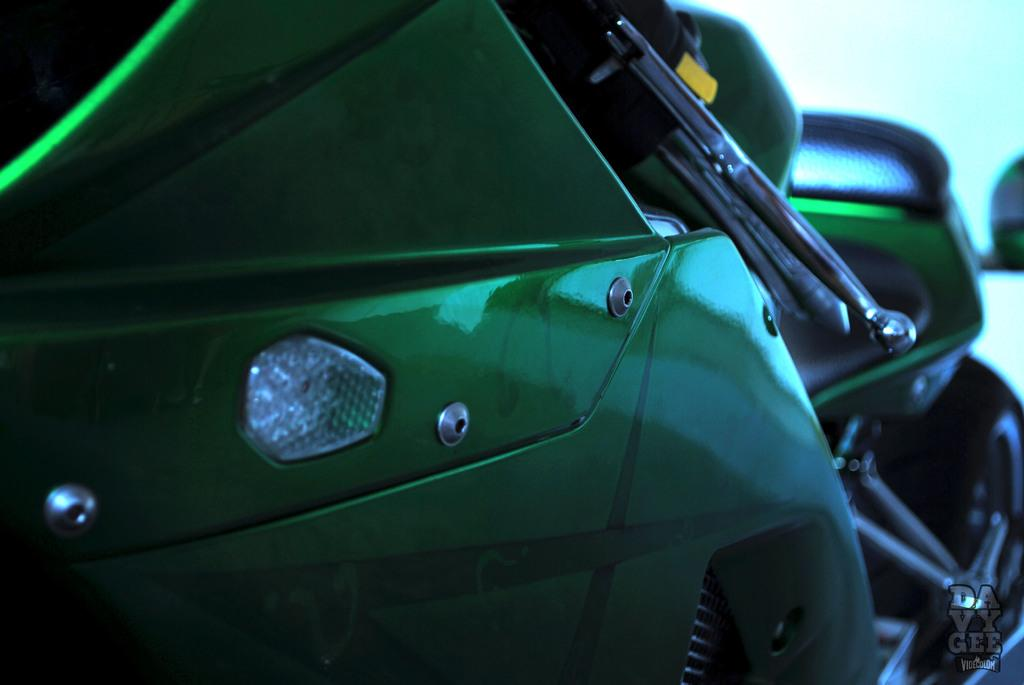What type of vehicle is in the image? There is a motorbike in the image. Can you describe the view of the motorbike? The view of the motorbike is close. Where is the squirrel in the image? There is no squirrel present in the image. What type of town or harbor can be seen in the image? There is no town or harbor present in the image; it only features a motorbike. 